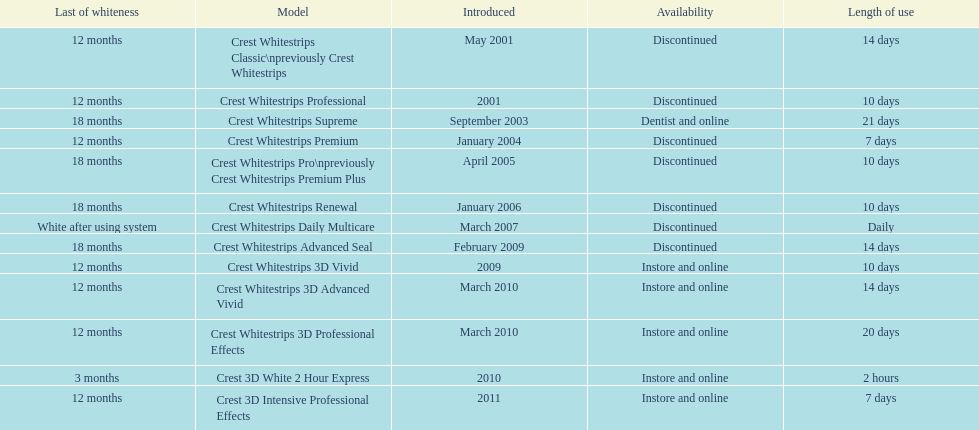Which product was to be used longer, crest whitestrips classic or crest whitestrips 3d vivid? Crest Whitestrips Classic. 